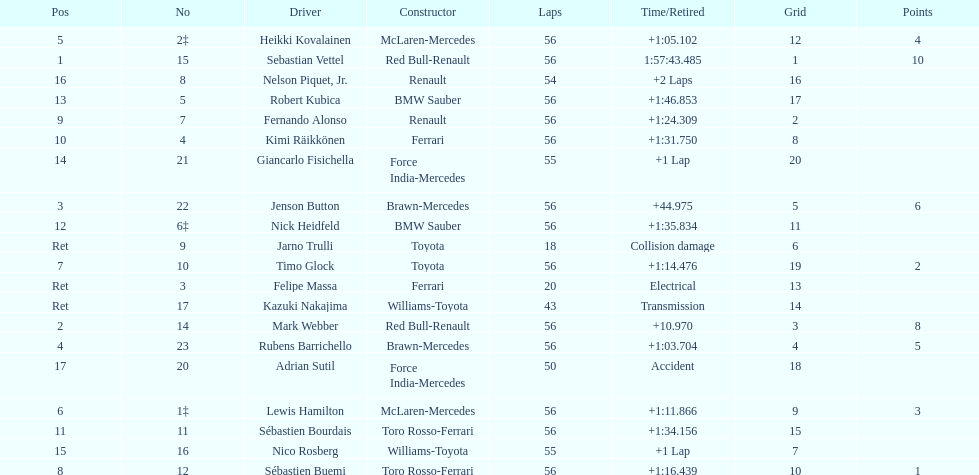How many laps in total is the race? 56. 